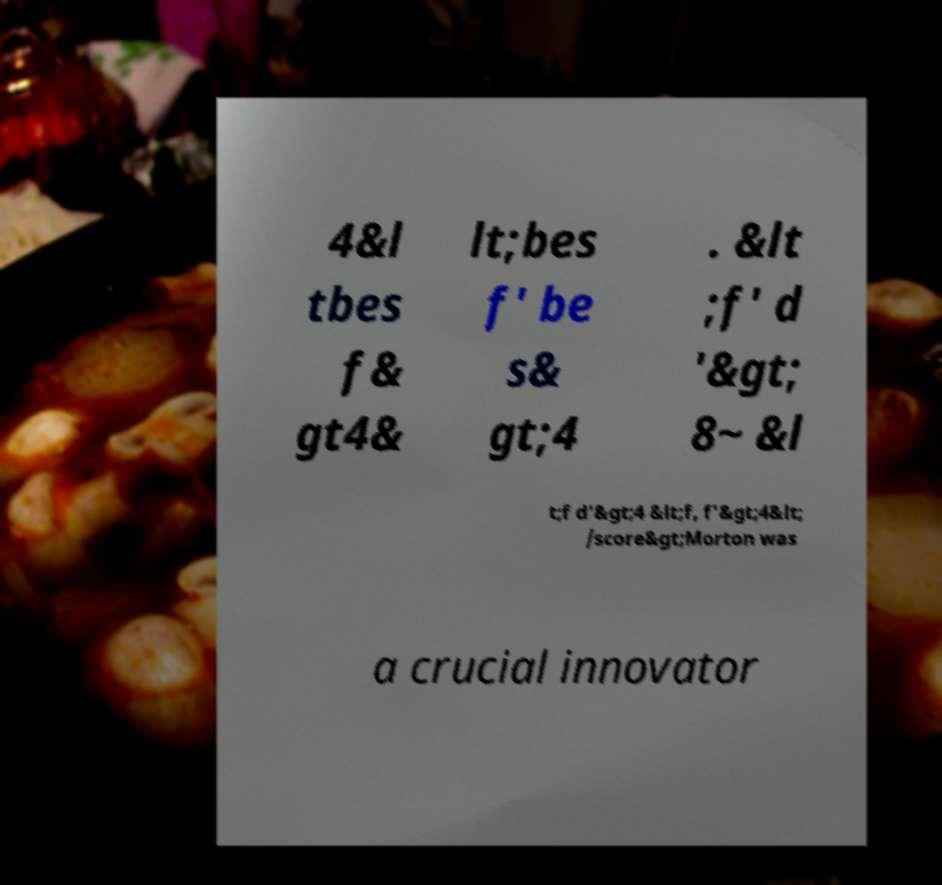Could you extract and type out the text from this image? 4&l tbes f& gt4& lt;bes f' be s& gt;4 . &lt ;f' d '&gt; 8~ &l t;f d'&gt;4 &lt;f, f'&gt;4&lt; /score&gt;Morton was a crucial innovator 